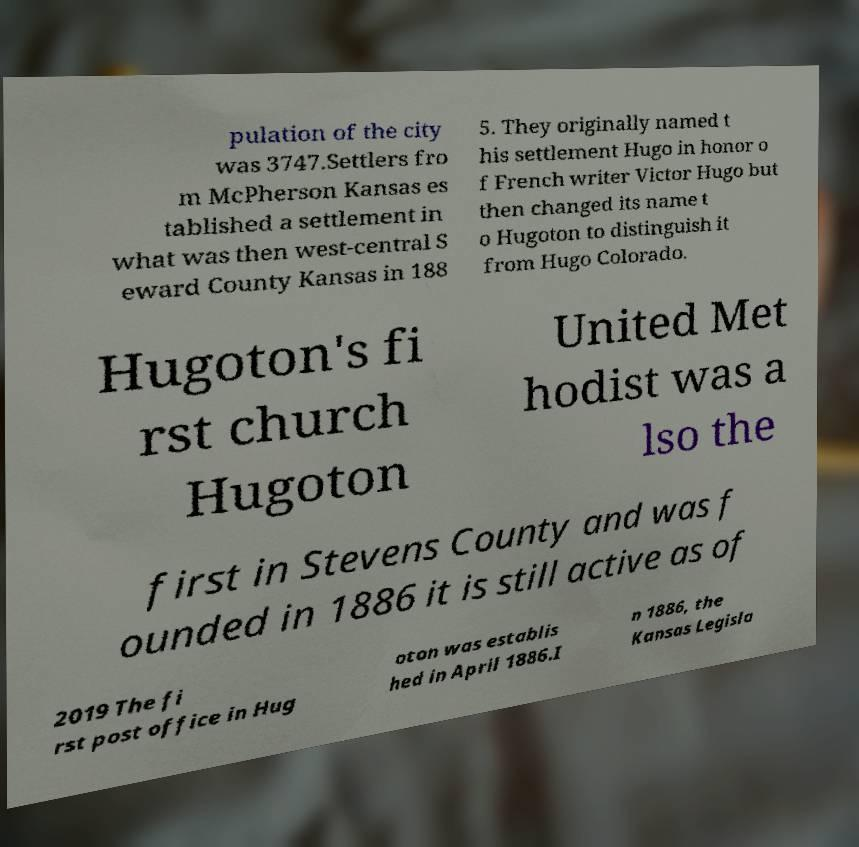There's text embedded in this image that I need extracted. Can you transcribe it verbatim? pulation of the city was 3747.Settlers fro m McPherson Kansas es tablished a settlement in what was then west-central S eward County Kansas in 188 5. They originally named t his settlement Hugo in honor o f French writer Victor Hugo but then changed its name t o Hugoton to distinguish it from Hugo Colorado. Hugoton's fi rst church Hugoton United Met hodist was a lso the first in Stevens County and was f ounded in 1886 it is still active as of 2019 The fi rst post office in Hug oton was establis hed in April 1886.I n 1886, the Kansas Legisla 